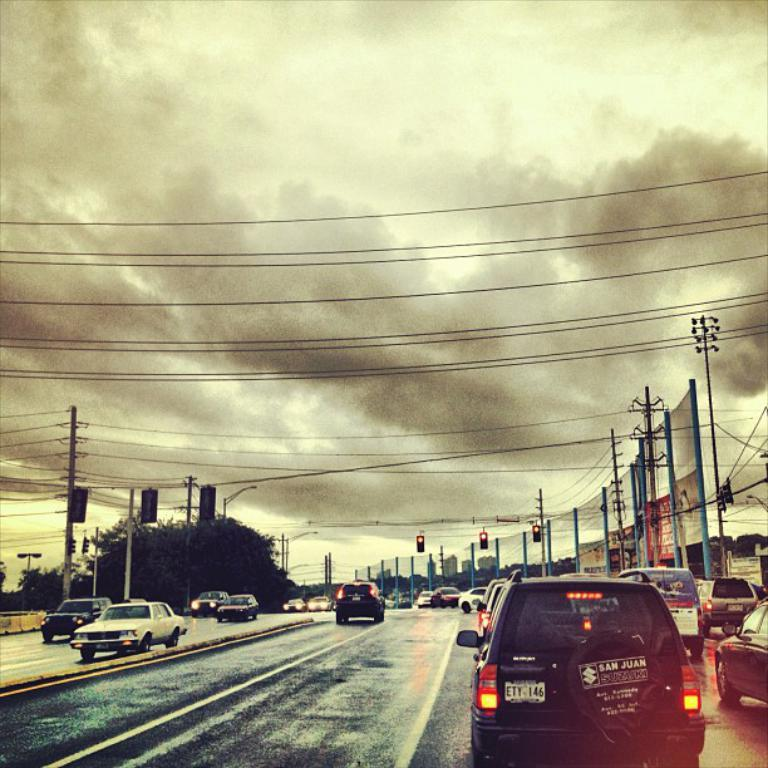What can be seen on the road in the image? There are many cars parked on the road in the image. What else is visible in the background of the image? There is a tree visible behind the parked cars. How many rabbits can be seen hopping around the parked cars in the image? There are no rabbits visible in the image; it only shows parked cars and a tree in the background. 